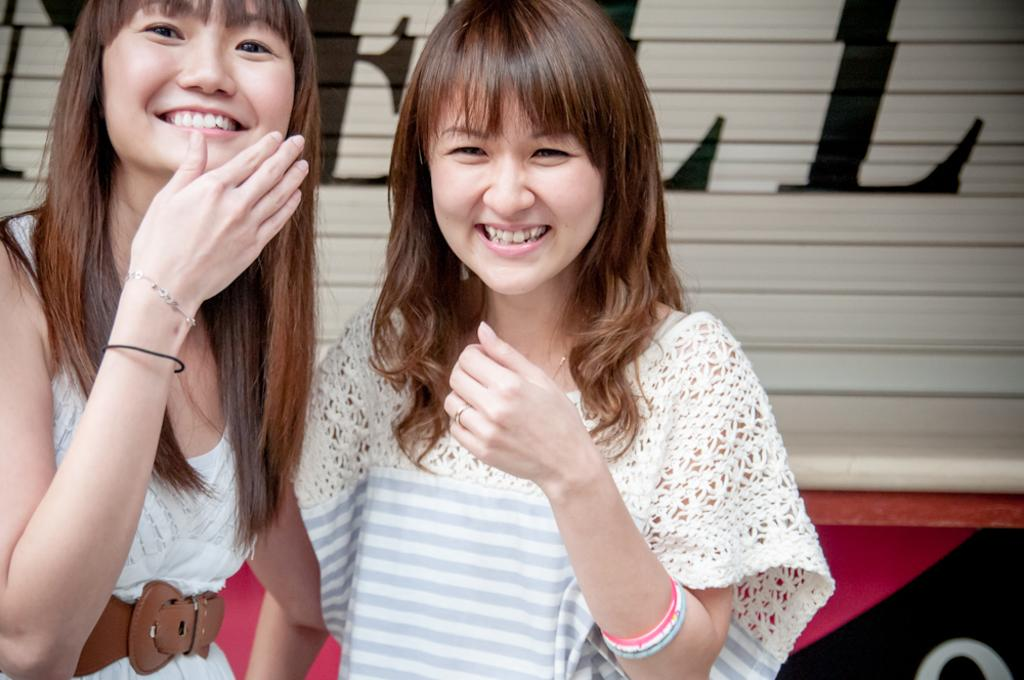How many people are in the image? There are two women in the image. What are the women doing in the image? The women are standing and smiling. Can you describe the background of the image? There is text on a shutter in the background of the image. What type of tank can be seen in the image? There is no tank present in the image. Can you describe the cemetery in the image? There is no cemetery present in the image. 